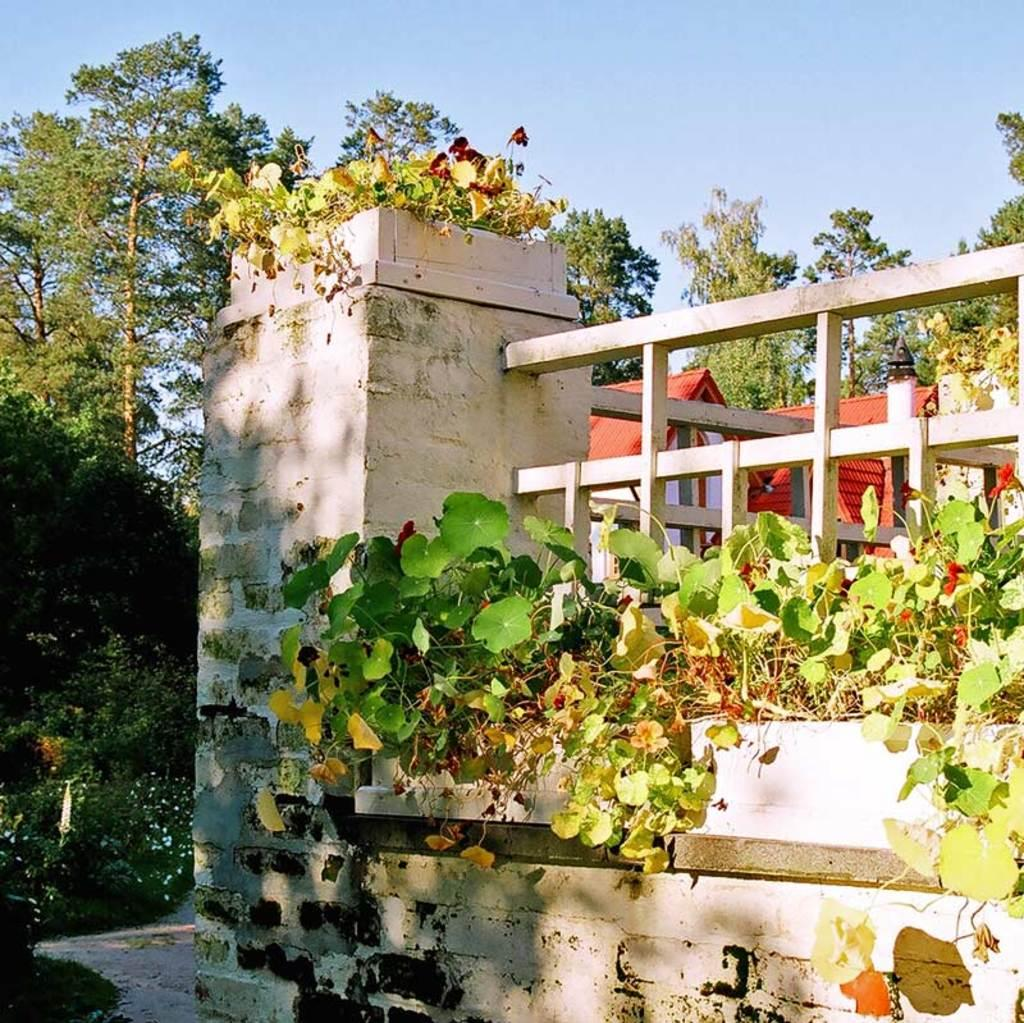What type of structures can be seen in the image? There are houses in the image. What type of vegetation is present in the image? There are trees, plants, and flowers in the image. What architectural feature can be seen in the image? There is a grille in the image. What type of climbing plants can be seen in the image? There are creepers in the image. What is visible in the background of the image? The sky is visible in the background of the image. How many kittens are playing on the edge of the grille in the image? There are no kittens present in the image. What type of power source is visible in the image? There is no power source visible in the image. 